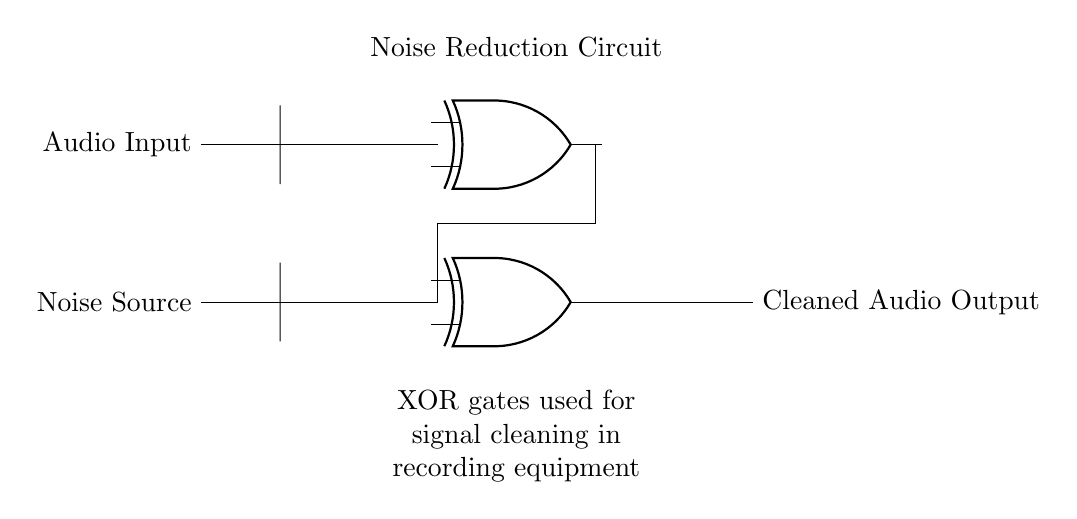What is the main component used for noise reduction in this circuit? The main components used for noise reduction in the circuit are two XOR gates. These gates process the audio signal and the noise signal to effectively reduce noise.
Answer: XOR gates How many input signals are there in this circuit? There are two input signals: one from the audio input and one from the noise source. Each signal connects to a different XOR gate.
Answer: Two What type of signals are being processed by the XOR gates? The XOR gates process an audio signal and a noise signal. The purpose is to clean up the audio signal by removing unwanted noise.
Answer: Audio and noise signals What does the output represent in this circuit? The output represents the cleaned audio signal after noise reduction has been applied through the XOR gates, providing an improved audio output for recording equipment.
Answer: Cleaned audio output Which component is used to combine the audio input and noise in this circuit? The component used to combine the audio input and noise is the XOR gate. It takes the two signals as input and outputs a cleaner audio signal by performing an exclusive OR operation.
Answer: XOR gate What is the relationship between the output and the noise source in this circuit? The relationship is that the output is determined by the XOR operation between the audio input and the noise source, effectively canceling out the noise components from the output signal.
Answer: Cancellation 